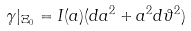Convert formula to latex. <formula><loc_0><loc_0><loc_500><loc_500>\gamma | _ { \Xi _ { 0 } } = I ( a ) ( d a ^ { 2 } + a ^ { 2 } d \vartheta ^ { 2 } )</formula> 